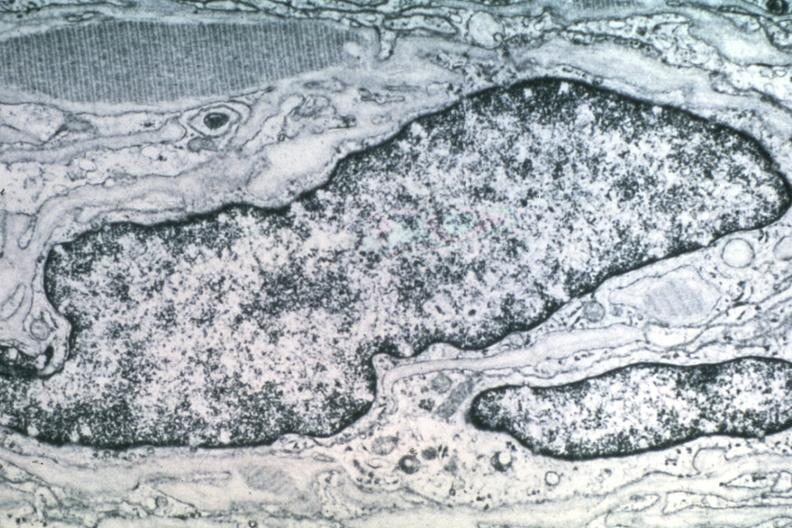does endometritis show dr garcia tumors 42?
Answer the question using a single word or phrase. No 